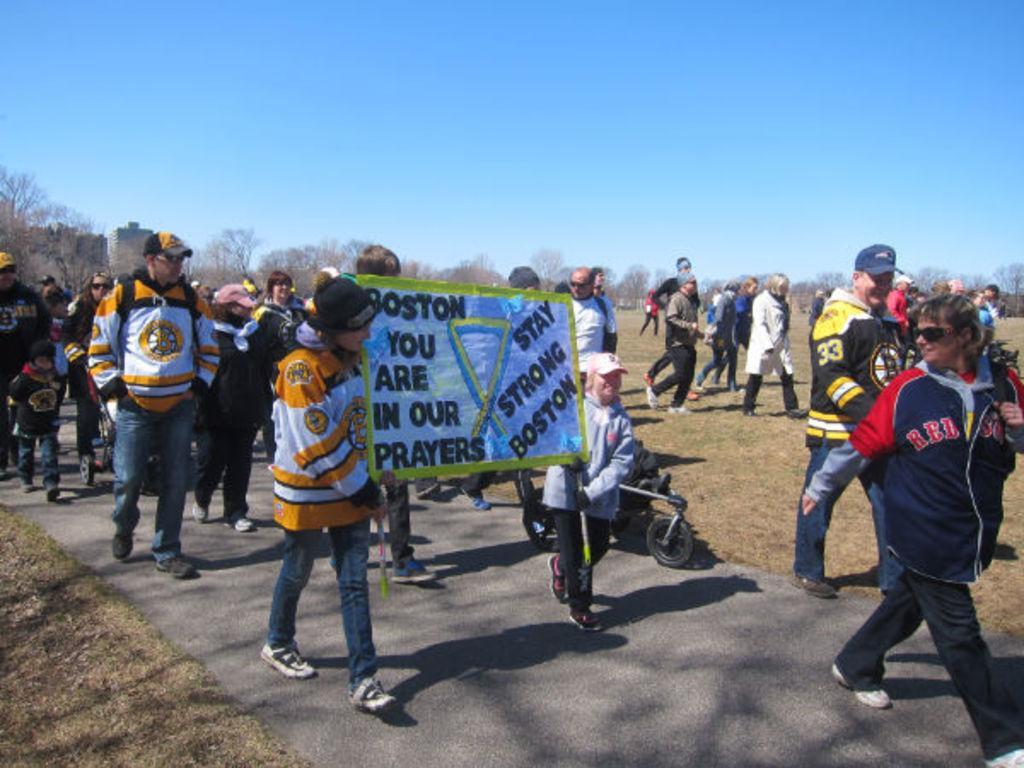Describe this image in one or two sentences. In this picture, we see many people are walking on the road. In front of the picture, we see two girls are holding a board which is in white and green color. We see some text written on it. I think they are protesting against something. Behind them, we see people are walking on the road. At the bottom, we see the road and the grass. There are trees in the background. At the top, we see the sky. 